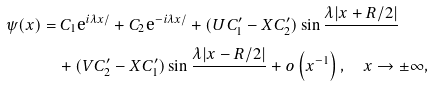Convert formula to latex. <formula><loc_0><loc_0><loc_500><loc_500>\psi ( x ) & = C _ { 1 } { \mbox e } ^ { i \lambda x / } + C _ { 2 } { \mbox e } ^ { - i \lambda x / } + ( U C ^ { \prime } _ { 1 } - X C ^ { \prime } _ { 2 } ) \sin { \frac { \lambda | x + R / 2 | } { } } \\ & \quad + ( V C ^ { \prime } _ { 2 } - X C ^ { \prime } _ { 1 } ) \sin { \frac { \lambda | x - R / 2 | } { } } + o \left ( x ^ { - 1 } \right ) , \quad x \rightarrow \pm \infty ,</formula> 